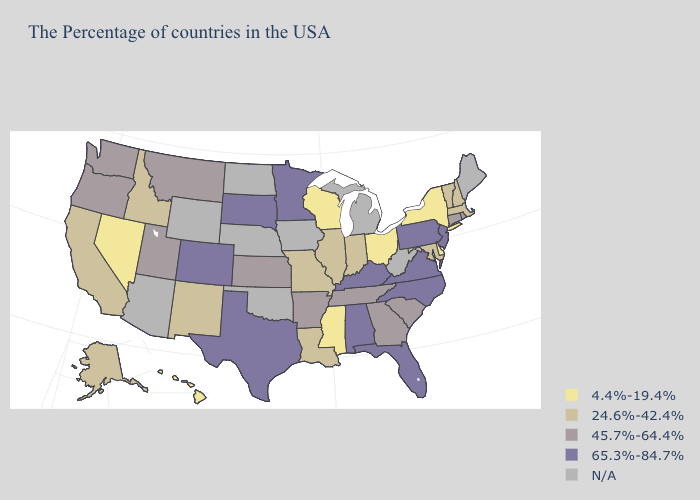Does the first symbol in the legend represent the smallest category?
Give a very brief answer. Yes. What is the value of Kentucky?
Answer briefly. 65.3%-84.7%. Name the states that have a value in the range 4.4%-19.4%?
Quick response, please. New York, Delaware, Ohio, Wisconsin, Mississippi, Nevada, Hawaii. Name the states that have a value in the range 45.7%-64.4%?
Answer briefly. Rhode Island, Connecticut, South Carolina, Georgia, Tennessee, Arkansas, Kansas, Utah, Montana, Washington, Oregon. Which states have the lowest value in the USA?
Short answer required. New York, Delaware, Ohio, Wisconsin, Mississippi, Nevada, Hawaii. What is the lowest value in states that border Missouri?
Answer briefly. 24.6%-42.4%. What is the value of Utah?
Write a very short answer. 45.7%-64.4%. Among the states that border Massachusetts , which have the highest value?
Concise answer only. Rhode Island, Connecticut. What is the value of North Carolina?
Quick response, please. 65.3%-84.7%. Name the states that have a value in the range 24.6%-42.4%?
Be succinct. Massachusetts, New Hampshire, Vermont, Maryland, Indiana, Illinois, Louisiana, Missouri, New Mexico, Idaho, California, Alaska. What is the highest value in the USA?
Be succinct. 65.3%-84.7%. Does Maryland have the lowest value in the USA?
Be succinct. No. What is the lowest value in states that border Arizona?
Keep it brief. 4.4%-19.4%. Among the states that border Minnesota , does Wisconsin have the highest value?
Answer briefly. No. 